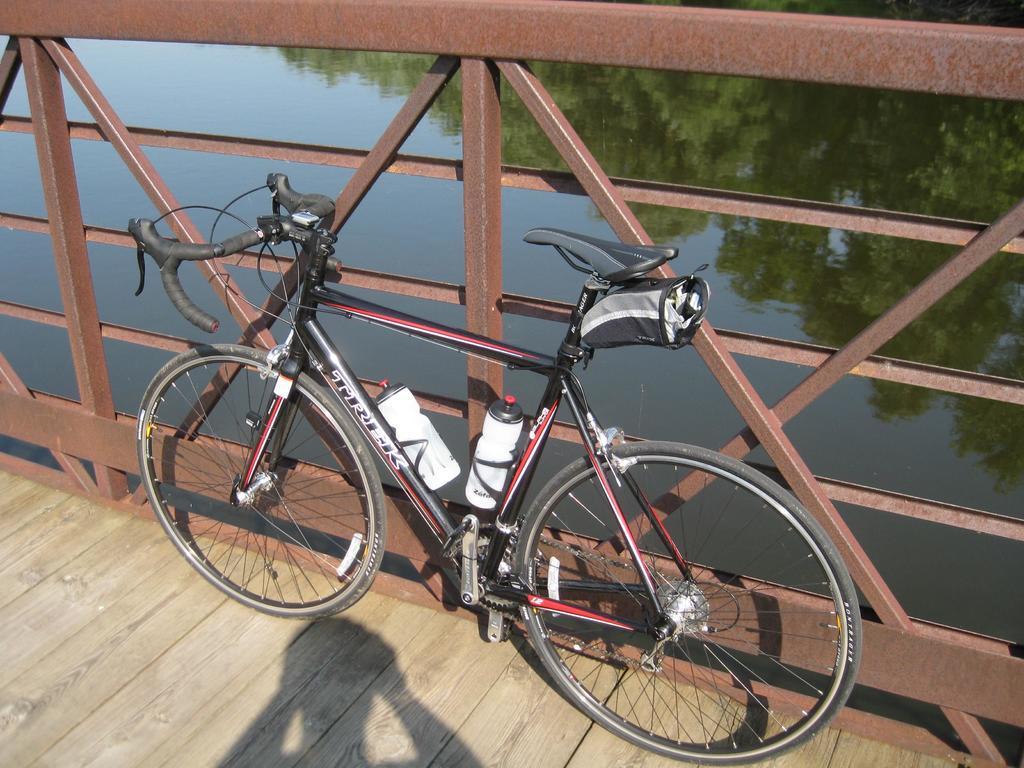Could you give a brief overview of what you see in this image? In this picture there is a bicycle which is parked near to the fencing. At the bottom I can see the shadow of a person on the wooden bridge. In the back I can see the water. In the water reflection I can see many trees and sky. 